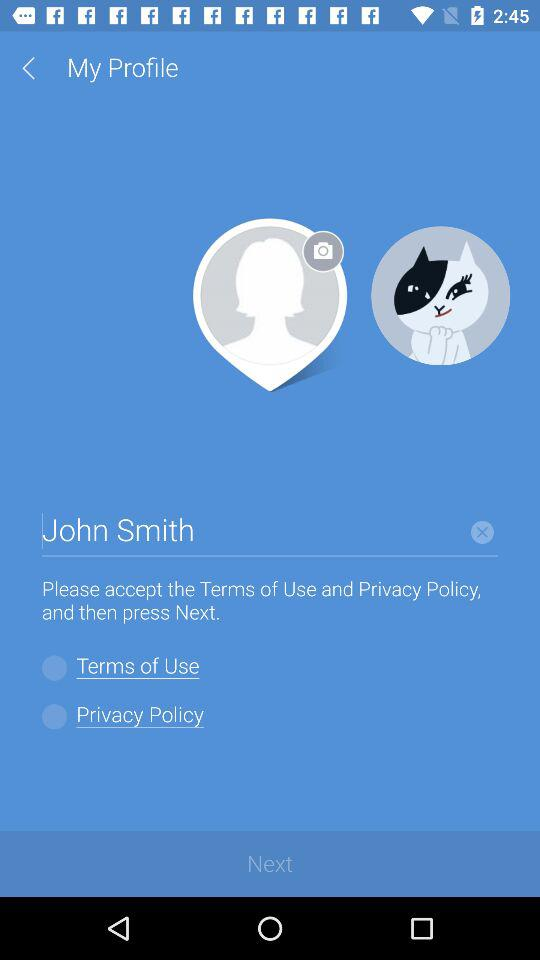What is the user name? The user name is John Smith. 